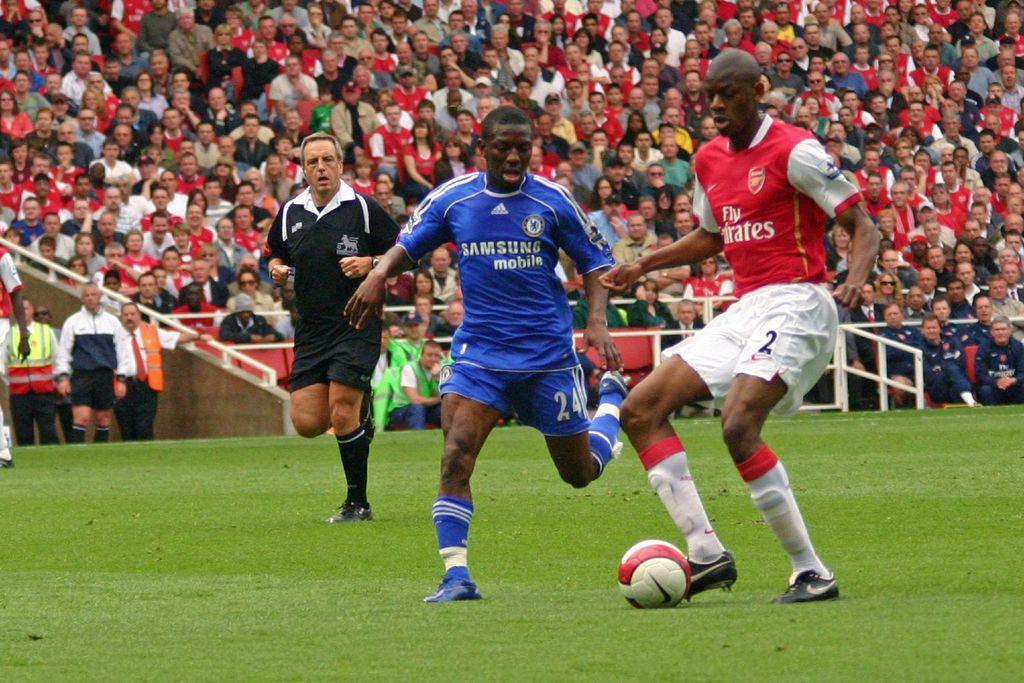Provide a one-sentence caption for the provided image. The soccer team wearing blue uniforms is sponsored by Samsung mobile. 